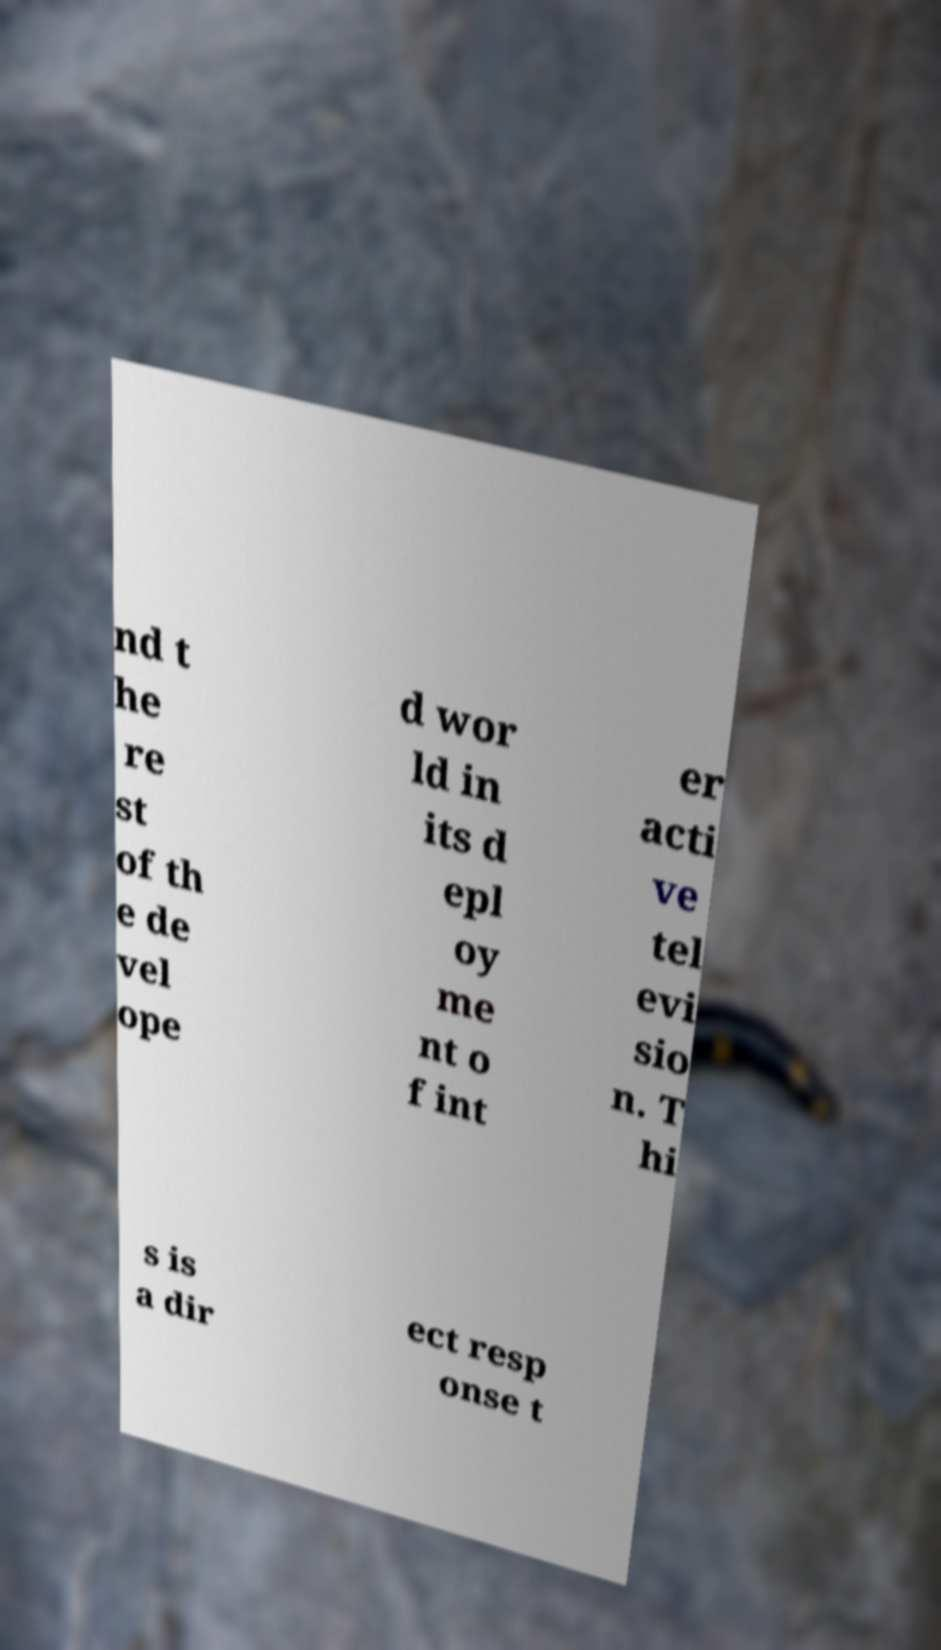There's text embedded in this image that I need extracted. Can you transcribe it verbatim? nd t he re st of th e de vel ope d wor ld in its d epl oy me nt o f int er acti ve tel evi sio n. T hi s is a dir ect resp onse t 